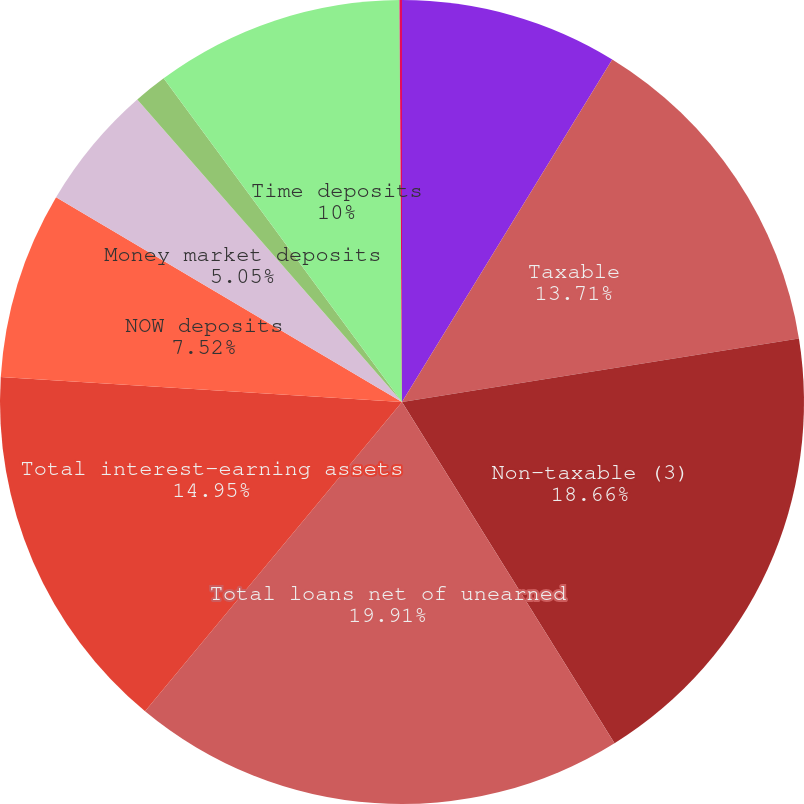<chart> <loc_0><loc_0><loc_500><loc_500><pie_chart><fcel>Federal Reserve deposits<fcel>Taxable<fcel>Non-taxable (3)<fcel>Total loans net of unearned<fcel>Total interest-earning assets<fcel>NOW deposits<fcel>Money market deposits<fcel>Money market deposits in<fcel>Time deposits<fcel>Sweep deposits in foreign<nl><fcel>8.76%<fcel>13.71%<fcel>18.66%<fcel>19.9%<fcel>14.95%<fcel>7.52%<fcel>5.05%<fcel>1.34%<fcel>10.0%<fcel>0.1%<nl></chart> 